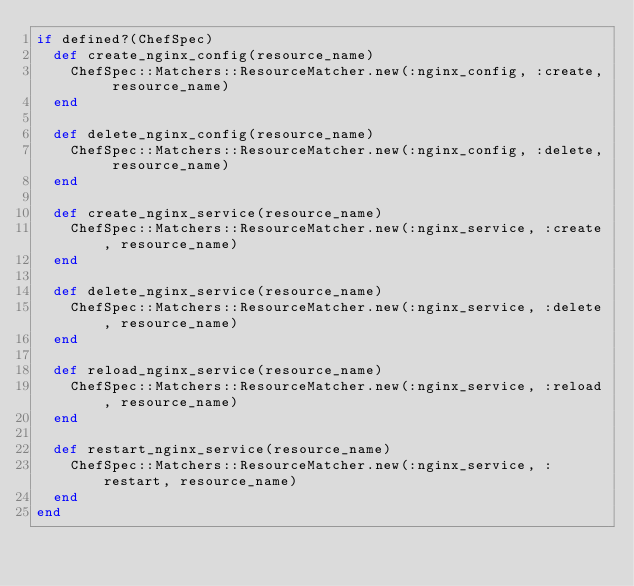<code> <loc_0><loc_0><loc_500><loc_500><_Ruby_>if defined?(ChefSpec)
  def create_nginx_config(resource_name)
    ChefSpec::Matchers::ResourceMatcher.new(:nginx_config, :create, resource_name)
  end

  def delete_nginx_config(resource_name)
    ChefSpec::Matchers::ResourceMatcher.new(:nginx_config, :delete, resource_name)
  end

  def create_nginx_service(resource_name)
    ChefSpec::Matchers::ResourceMatcher.new(:nginx_service, :create, resource_name)
  end

  def delete_nginx_service(resource_name)
    ChefSpec::Matchers::ResourceMatcher.new(:nginx_service, :delete, resource_name)
  end

  def reload_nginx_service(resource_name)
    ChefSpec::Matchers::ResourceMatcher.new(:nginx_service, :reload, resource_name)
  end

  def restart_nginx_service(resource_name)
    ChefSpec::Matchers::ResourceMatcher.new(:nginx_service, :restart, resource_name)
  end
end
</code> 